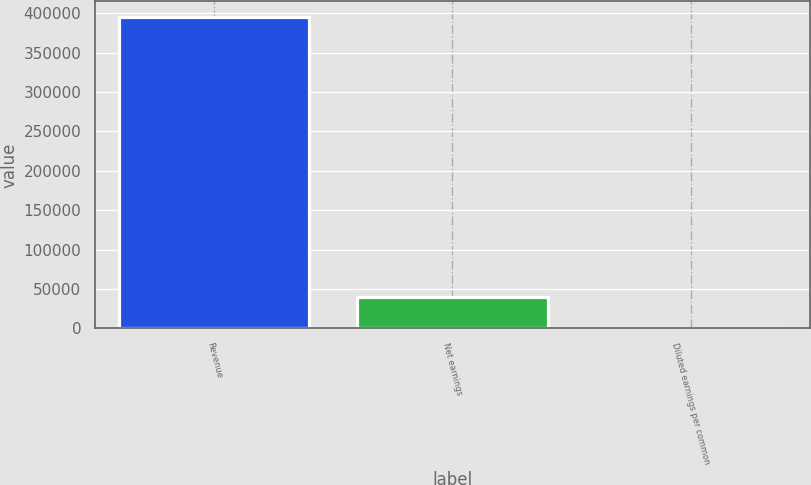Convert chart to OTSL. <chart><loc_0><loc_0><loc_500><loc_500><bar_chart><fcel>Revenue<fcel>Net earnings<fcel>Diluted earnings per common<nl><fcel>395155<fcel>39516.4<fcel>1<nl></chart> 